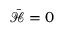Convert formula to latex. <formula><loc_0><loc_0><loc_500><loc_500>\bar { \mathcal { H } } = 0</formula> 